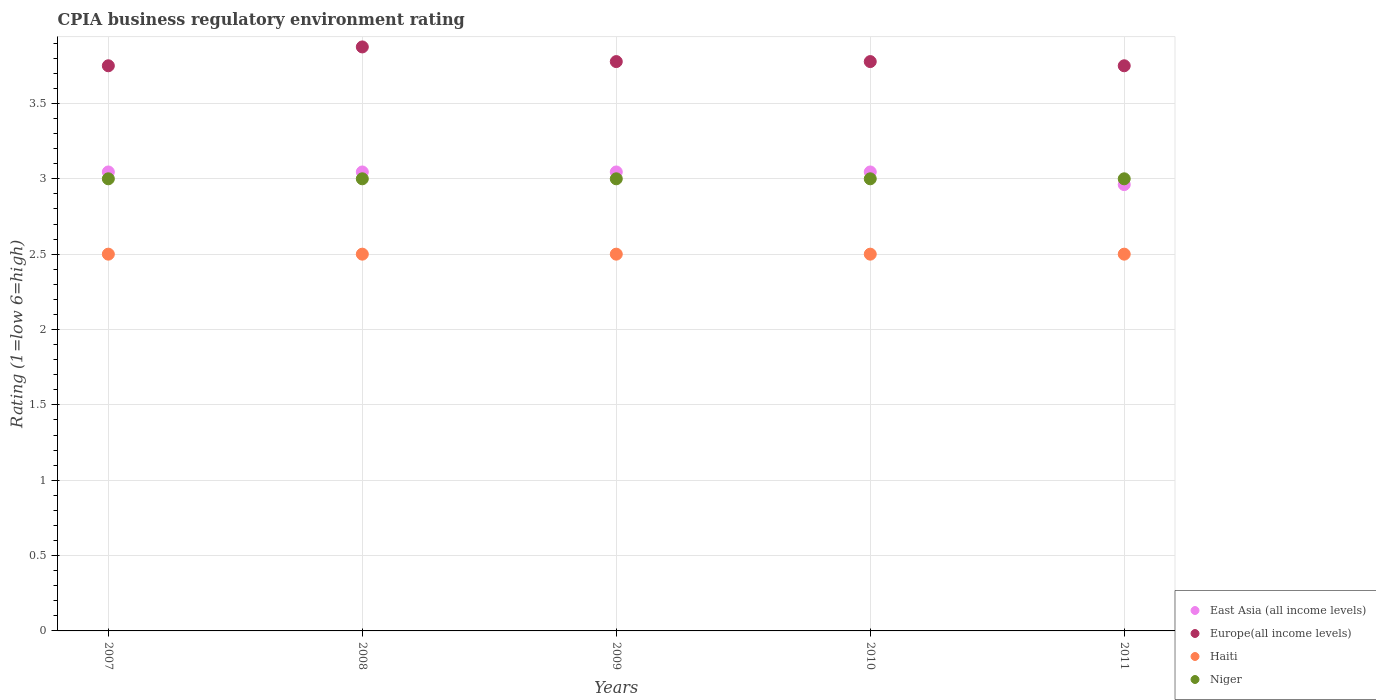How many different coloured dotlines are there?
Provide a short and direct response. 4. Is the number of dotlines equal to the number of legend labels?
Your answer should be compact. Yes. What is the CPIA rating in Europe(all income levels) in 2010?
Ensure brevity in your answer.  3.78. Across all years, what is the maximum CPIA rating in East Asia (all income levels)?
Your answer should be very brief. 3.05. Across all years, what is the minimum CPIA rating in Haiti?
Make the answer very short. 2.5. In which year was the CPIA rating in Haiti maximum?
Offer a terse response. 2007. In which year was the CPIA rating in Niger minimum?
Offer a very short reply. 2007. What is the total CPIA rating in Europe(all income levels) in the graph?
Give a very brief answer. 18.93. What is the difference between the CPIA rating in Europe(all income levels) in 2010 and the CPIA rating in Niger in 2009?
Provide a succinct answer. 0.78. What is the average CPIA rating in Europe(all income levels) per year?
Your answer should be compact. 3.79. In the year 2008, what is the difference between the CPIA rating in Europe(all income levels) and CPIA rating in East Asia (all income levels)?
Make the answer very short. 0.83. In how many years, is the CPIA rating in Haiti greater than 3.6?
Ensure brevity in your answer.  0. Is the difference between the CPIA rating in Europe(all income levels) in 2008 and 2009 greater than the difference between the CPIA rating in East Asia (all income levels) in 2008 and 2009?
Offer a very short reply. Yes. Is the sum of the CPIA rating in East Asia (all income levels) in 2010 and 2011 greater than the maximum CPIA rating in Niger across all years?
Give a very brief answer. Yes. Is it the case that in every year, the sum of the CPIA rating in Europe(all income levels) and CPIA rating in Niger  is greater than the sum of CPIA rating in Haiti and CPIA rating in East Asia (all income levels)?
Make the answer very short. Yes. Is the CPIA rating in Niger strictly greater than the CPIA rating in Haiti over the years?
Your answer should be very brief. Yes. How many dotlines are there?
Ensure brevity in your answer.  4. How many years are there in the graph?
Make the answer very short. 5. Are the values on the major ticks of Y-axis written in scientific E-notation?
Provide a short and direct response. No. Does the graph contain any zero values?
Provide a short and direct response. No. Where does the legend appear in the graph?
Ensure brevity in your answer.  Bottom right. What is the title of the graph?
Your response must be concise. CPIA business regulatory environment rating. Does "Colombia" appear as one of the legend labels in the graph?
Your answer should be compact. No. What is the label or title of the X-axis?
Your answer should be very brief. Years. What is the label or title of the Y-axis?
Keep it short and to the point. Rating (1=low 6=high). What is the Rating (1=low 6=high) of East Asia (all income levels) in 2007?
Offer a very short reply. 3.05. What is the Rating (1=low 6=high) of Europe(all income levels) in 2007?
Provide a short and direct response. 3.75. What is the Rating (1=low 6=high) of East Asia (all income levels) in 2008?
Provide a succinct answer. 3.05. What is the Rating (1=low 6=high) of Europe(all income levels) in 2008?
Keep it short and to the point. 3.88. What is the Rating (1=low 6=high) of East Asia (all income levels) in 2009?
Your response must be concise. 3.05. What is the Rating (1=low 6=high) of Europe(all income levels) in 2009?
Offer a very short reply. 3.78. What is the Rating (1=low 6=high) in Niger in 2009?
Provide a succinct answer. 3. What is the Rating (1=low 6=high) of East Asia (all income levels) in 2010?
Make the answer very short. 3.05. What is the Rating (1=low 6=high) in Europe(all income levels) in 2010?
Provide a short and direct response. 3.78. What is the Rating (1=low 6=high) in Haiti in 2010?
Give a very brief answer. 2.5. What is the Rating (1=low 6=high) in Niger in 2010?
Make the answer very short. 3. What is the Rating (1=low 6=high) of East Asia (all income levels) in 2011?
Make the answer very short. 2.96. What is the Rating (1=low 6=high) of Europe(all income levels) in 2011?
Provide a short and direct response. 3.75. What is the Rating (1=low 6=high) of Haiti in 2011?
Offer a terse response. 2.5. What is the Rating (1=low 6=high) in Niger in 2011?
Offer a terse response. 3. Across all years, what is the maximum Rating (1=low 6=high) of East Asia (all income levels)?
Offer a terse response. 3.05. Across all years, what is the maximum Rating (1=low 6=high) in Europe(all income levels)?
Your response must be concise. 3.88. Across all years, what is the minimum Rating (1=low 6=high) of East Asia (all income levels)?
Offer a very short reply. 2.96. Across all years, what is the minimum Rating (1=low 6=high) in Europe(all income levels)?
Offer a terse response. 3.75. What is the total Rating (1=low 6=high) in East Asia (all income levels) in the graph?
Give a very brief answer. 15.14. What is the total Rating (1=low 6=high) of Europe(all income levels) in the graph?
Provide a succinct answer. 18.93. What is the total Rating (1=low 6=high) of Haiti in the graph?
Provide a short and direct response. 12.5. What is the total Rating (1=low 6=high) in Niger in the graph?
Your answer should be compact. 15. What is the difference between the Rating (1=low 6=high) of Europe(all income levels) in 2007 and that in 2008?
Your response must be concise. -0.12. What is the difference between the Rating (1=low 6=high) of Haiti in 2007 and that in 2008?
Ensure brevity in your answer.  0. What is the difference between the Rating (1=low 6=high) in Europe(all income levels) in 2007 and that in 2009?
Provide a short and direct response. -0.03. What is the difference between the Rating (1=low 6=high) of Haiti in 2007 and that in 2009?
Provide a succinct answer. 0. What is the difference between the Rating (1=low 6=high) in East Asia (all income levels) in 2007 and that in 2010?
Provide a succinct answer. 0. What is the difference between the Rating (1=low 6=high) of Europe(all income levels) in 2007 and that in 2010?
Offer a very short reply. -0.03. What is the difference between the Rating (1=low 6=high) of Haiti in 2007 and that in 2010?
Your answer should be compact. 0. What is the difference between the Rating (1=low 6=high) in East Asia (all income levels) in 2007 and that in 2011?
Provide a short and direct response. 0.08. What is the difference between the Rating (1=low 6=high) of Niger in 2007 and that in 2011?
Provide a short and direct response. 0. What is the difference between the Rating (1=low 6=high) in Europe(all income levels) in 2008 and that in 2009?
Your answer should be very brief. 0.1. What is the difference between the Rating (1=low 6=high) of Haiti in 2008 and that in 2009?
Give a very brief answer. 0. What is the difference between the Rating (1=low 6=high) of Niger in 2008 and that in 2009?
Keep it short and to the point. 0. What is the difference between the Rating (1=low 6=high) of East Asia (all income levels) in 2008 and that in 2010?
Provide a succinct answer. 0. What is the difference between the Rating (1=low 6=high) in Europe(all income levels) in 2008 and that in 2010?
Your response must be concise. 0.1. What is the difference between the Rating (1=low 6=high) in Haiti in 2008 and that in 2010?
Keep it short and to the point. 0. What is the difference between the Rating (1=low 6=high) in East Asia (all income levels) in 2008 and that in 2011?
Make the answer very short. 0.08. What is the difference between the Rating (1=low 6=high) in Europe(all income levels) in 2008 and that in 2011?
Your answer should be compact. 0.12. What is the difference between the Rating (1=low 6=high) of Haiti in 2008 and that in 2011?
Provide a succinct answer. 0. What is the difference between the Rating (1=low 6=high) of East Asia (all income levels) in 2009 and that in 2010?
Give a very brief answer. 0. What is the difference between the Rating (1=low 6=high) of Haiti in 2009 and that in 2010?
Offer a very short reply. 0. What is the difference between the Rating (1=low 6=high) of East Asia (all income levels) in 2009 and that in 2011?
Offer a very short reply. 0.08. What is the difference between the Rating (1=low 6=high) of Europe(all income levels) in 2009 and that in 2011?
Provide a succinct answer. 0.03. What is the difference between the Rating (1=low 6=high) in Haiti in 2009 and that in 2011?
Ensure brevity in your answer.  0. What is the difference between the Rating (1=low 6=high) in East Asia (all income levels) in 2010 and that in 2011?
Ensure brevity in your answer.  0.08. What is the difference between the Rating (1=low 6=high) in Europe(all income levels) in 2010 and that in 2011?
Provide a short and direct response. 0.03. What is the difference between the Rating (1=low 6=high) of East Asia (all income levels) in 2007 and the Rating (1=low 6=high) of Europe(all income levels) in 2008?
Ensure brevity in your answer.  -0.83. What is the difference between the Rating (1=low 6=high) of East Asia (all income levels) in 2007 and the Rating (1=low 6=high) of Haiti in 2008?
Give a very brief answer. 0.55. What is the difference between the Rating (1=low 6=high) of East Asia (all income levels) in 2007 and the Rating (1=low 6=high) of Niger in 2008?
Provide a short and direct response. 0.05. What is the difference between the Rating (1=low 6=high) of Europe(all income levels) in 2007 and the Rating (1=low 6=high) of Haiti in 2008?
Your response must be concise. 1.25. What is the difference between the Rating (1=low 6=high) of Europe(all income levels) in 2007 and the Rating (1=low 6=high) of Niger in 2008?
Offer a very short reply. 0.75. What is the difference between the Rating (1=low 6=high) of East Asia (all income levels) in 2007 and the Rating (1=low 6=high) of Europe(all income levels) in 2009?
Your answer should be compact. -0.73. What is the difference between the Rating (1=low 6=high) of East Asia (all income levels) in 2007 and the Rating (1=low 6=high) of Haiti in 2009?
Make the answer very short. 0.55. What is the difference between the Rating (1=low 6=high) of East Asia (all income levels) in 2007 and the Rating (1=low 6=high) of Niger in 2009?
Give a very brief answer. 0.05. What is the difference between the Rating (1=low 6=high) of Europe(all income levels) in 2007 and the Rating (1=low 6=high) of Haiti in 2009?
Ensure brevity in your answer.  1.25. What is the difference between the Rating (1=low 6=high) in Europe(all income levels) in 2007 and the Rating (1=low 6=high) in Niger in 2009?
Make the answer very short. 0.75. What is the difference between the Rating (1=low 6=high) of East Asia (all income levels) in 2007 and the Rating (1=low 6=high) of Europe(all income levels) in 2010?
Ensure brevity in your answer.  -0.73. What is the difference between the Rating (1=low 6=high) in East Asia (all income levels) in 2007 and the Rating (1=low 6=high) in Haiti in 2010?
Your answer should be compact. 0.55. What is the difference between the Rating (1=low 6=high) of East Asia (all income levels) in 2007 and the Rating (1=low 6=high) of Niger in 2010?
Ensure brevity in your answer.  0.05. What is the difference between the Rating (1=low 6=high) of Europe(all income levels) in 2007 and the Rating (1=low 6=high) of Niger in 2010?
Your answer should be compact. 0.75. What is the difference between the Rating (1=low 6=high) of East Asia (all income levels) in 2007 and the Rating (1=low 6=high) of Europe(all income levels) in 2011?
Offer a very short reply. -0.7. What is the difference between the Rating (1=low 6=high) of East Asia (all income levels) in 2007 and the Rating (1=low 6=high) of Haiti in 2011?
Your answer should be compact. 0.55. What is the difference between the Rating (1=low 6=high) of East Asia (all income levels) in 2007 and the Rating (1=low 6=high) of Niger in 2011?
Offer a terse response. 0.05. What is the difference between the Rating (1=low 6=high) in Europe(all income levels) in 2007 and the Rating (1=low 6=high) in Haiti in 2011?
Make the answer very short. 1.25. What is the difference between the Rating (1=low 6=high) of Europe(all income levels) in 2007 and the Rating (1=low 6=high) of Niger in 2011?
Provide a short and direct response. 0.75. What is the difference between the Rating (1=low 6=high) in East Asia (all income levels) in 2008 and the Rating (1=low 6=high) in Europe(all income levels) in 2009?
Provide a short and direct response. -0.73. What is the difference between the Rating (1=low 6=high) of East Asia (all income levels) in 2008 and the Rating (1=low 6=high) of Haiti in 2009?
Give a very brief answer. 0.55. What is the difference between the Rating (1=low 6=high) in East Asia (all income levels) in 2008 and the Rating (1=low 6=high) in Niger in 2009?
Your response must be concise. 0.05. What is the difference between the Rating (1=low 6=high) of Europe(all income levels) in 2008 and the Rating (1=low 6=high) of Haiti in 2009?
Keep it short and to the point. 1.38. What is the difference between the Rating (1=low 6=high) of Haiti in 2008 and the Rating (1=low 6=high) of Niger in 2009?
Keep it short and to the point. -0.5. What is the difference between the Rating (1=low 6=high) of East Asia (all income levels) in 2008 and the Rating (1=low 6=high) of Europe(all income levels) in 2010?
Make the answer very short. -0.73. What is the difference between the Rating (1=low 6=high) in East Asia (all income levels) in 2008 and the Rating (1=low 6=high) in Haiti in 2010?
Make the answer very short. 0.55. What is the difference between the Rating (1=low 6=high) of East Asia (all income levels) in 2008 and the Rating (1=low 6=high) of Niger in 2010?
Your response must be concise. 0.05. What is the difference between the Rating (1=low 6=high) of Europe(all income levels) in 2008 and the Rating (1=low 6=high) of Haiti in 2010?
Provide a succinct answer. 1.38. What is the difference between the Rating (1=low 6=high) of Haiti in 2008 and the Rating (1=low 6=high) of Niger in 2010?
Offer a terse response. -0.5. What is the difference between the Rating (1=low 6=high) of East Asia (all income levels) in 2008 and the Rating (1=low 6=high) of Europe(all income levels) in 2011?
Give a very brief answer. -0.7. What is the difference between the Rating (1=low 6=high) in East Asia (all income levels) in 2008 and the Rating (1=low 6=high) in Haiti in 2011?
Ensure brevity in your answer.  0.55. What is the difference between the Rating (1=low 6=high) in East Asia (all income levels) in 2008 and the Rating (1=low 6=high) in Niger in 2011?
Your response must be concise. 0.05. What is the difference between the Rating (1=low 6=high) of Europe(all income levels) in 2008 and the Rating (1=low 6=high) of Haiti in 2011?
Ensure brevity in your answer.  1.38. What is the difference between the Rating (1=low 6=high) in Haiti in 2008 and the Rating (1=low 6=high) in Niger in 2011?
Make the answer very short. -0.5. What is the difference between the Rating (1=low 6=high) of East Asia (all income levels) in 2009 and the Rating (1=low 6=high) of Europe(all income levels) in 2010?
Keep it short and to the point. -0.73. What is the difference between the Rating (1=low 6=high) in East Asia (all income levels) in 2009 and the Rating (1=low 6=high) in Haiti in 2010?
Make the answer very short. 0.55. What is the difference between the Rating (1=low 6=high) in East Asia (all income levels) in 2009 and the Rating (1=low 6=high) in Niger in 2010?
Provide a succinct answer. 0.05. What is the difference between the Rating (1=low 6=high) in Europe(all income levels) in 2009 and the Rating (1=low 6=high) in Haiti in 2010?
Your answer should be compact. 1.28. What is the difference between the Rating (1=low 6=high) of Europe(all income levels) in 2009 and the Rating (1=low 6=high) of Niger in 2010?
Your answer should be compact. 0.78. What is the difference between the Rating (1=low 6=high) of East Asia (all income levels) in 2009 and the Rating (1=low 6=high) of Europe(all income levels) in 2011?
Keep it short and to the point. -0.7. What is the difference between the Rating (1=low 6=high) of East Asia (all income levels) in 2009 and the Rating (1=low 6=high) of Haiti in 2011?
Keep it short and to the point. 0.55. What is the difference between the Rating (1=low 6=high) in East Asia (all income levels) in 2009 and the Rating (1=low 6=high) in Niger in 2011?
Ensure brevity in your answer.  0.05. What is the difference between the Rating (1=low 6=high) of Europe(all income levels) in 2009 and the Rating (1=low 6=high) of Haiti in 2011?
Ensure brevity in your answer.  1.28. What is the difference between the Rating (1=low 6=high) of Europe(all income levels) in 2009 and the Rating (1=low 6=high) of Niger in 2011?
Your answer should be very brief. 0.78. What is the difference between the Rating (1=low 6=high) of Haiti in 2009 and the Rating (1=low 6=high) of Niger in 2011?
Ensure brevity in your answer.  -0.5. What is the difference between the Rating (1=low 6=high) in East Asia (all income levels) in 2010 and the Rating (1=low 6=high) in Europe(all income levels) in 2011?
Your response must be concise. -0.7. What is the difference between the Rating (1=low 6=high) of East Asia (all income levels) in 2010 and the Rating (1=low 6=high) of Haiti in 2011?
Your response must be concise. 0.55. What is the difference between the Rating (1=low 6=high) of East Asia (all income levels) in 2010 and the Rating (1=low 6=high) of Niger in 2011?
Your response must be concise. 0.05. What is the difference between the Rating (1=low 6=high) in Europe(all income levels) in 2010 and the Rating (1=low 6=high) in Haiti in 2011?
Your response must be concise. 1.28. What is the difference between the Rating (1=low 6=high) in Haiti in 2010 and the Rating (1=low 6=high) in Niger in 2011?
Your answer should be very brief. -0.5. What is the average Rating (1=low 6=high) in East Asia (all income levels) per year?
Provide a succinct answer. 3.03. What is the average Rating (1=low 6=high) in Europe(all income levels) per year?
Keep it short and to the point. 3.79. What is the average Rating (1=low 6=high) of Niger per year?
Keep it short and to the point. 3. In the year 2007, what is the difference between the Rating (1=low 6=high) of East Asia (all income levels) and Rating (1=low 6=high) of Europe(all income levels)?
Your answer should be compact. -0.7. In the year 2007, what is the difference between the Rating (1=low 6=high) in East Asia (all income levels) and Rating (1=low 6=high) in Haiti?
Ensure brevity in your answer.  0.55. In the year 2007, what is the difference between the Rating (1=low 6=high) of East Asia (all income levels) and Rating (1=low 6=high) of Niger?
Your answer should be compact. 0.05. In the year 2007, what is the difference between the Rating (1=low 6=high) in Europe(all income levels) and Rating (1=low 6=high) in Haiti?
Provide a succinct answer. 1.25. In the year 2007, what is the difference between the Rating (1=low 6=high) of Europe(all income levels) and Rating (1=low 6=high) of Niger?
Provide a short and direct response. 0.75. In the year 2008, what is the difference between the Rating (1=low 6=high) in East Asia (all income levels) and Rating (1=low 6=high) in Europe(all income levels)?
Offer a very short reply. -0.83. In the year 2008, what is the difference between the Rating (1=low 6=high) of East Asia (all income levels) and Rating (1=low 6=high) of Haiti?
Your answer should be compact. 0.55. In the year 2008, what is the difference between the Rating (1=low 6=high) in East Asia (all income levels) and Rating (1=low 6=high) in Niger?
Provide a short and direct response. 0.05. In the year 2008, what is the difference between the Rating (1=low 6=high) of Europe(all income levels) and Rating (1=low 6=high) of Haiti?
Make the answer very short. 1.38. In the year 2009, what is the difference between the Rating (1=low 6=high) in East Asia (all income levels) and Rating (1=low 6=high) in Europe(all income levels)?
Make the answer very short. -0.73. In the year 2009, what is the difference between the Rating (1=low 6=high) of East Asia (all income levels) and Rating (1=low 6=high) of Haiti?
Your response must be concise. 0.55. In the year 2009, what is the difference between the Rating (1=low 6=high) of East Asia (all income levels) and Rating (1=low 6=high) of Niger?
Keep it short and to the point. 0.05. In the year 2009, what is the difference between the Rating (1=low 6=high) in Europe(all income levels) and Rating (1=low 6=high) in Haiti?
Make the answer very short. 1.28. In the year 2010, what is the difference between the Rating (1=low 6=high) in East Asia (all income levels) and Rating (1=low 6=high) in Europe(all income levels)?
Give a very brief answer. -0.73. In the year 2010, what is the difference between the Rating (1=low 6=high) in East Asia (all income levels) and Rating (1=low 6=high) in Haiti?
Give a very brief answer. 0.55. In the year 2010, what is the difference between the Rating (1=low 6=high) in East Asia (all income levels) and Rating (1=low 6=high) in Niger?
Make the answer very short. 0.05. In the year 2010, what is the difference between the Rating (1=low 6=high) of Europe(all income levels) and Rating (1=low 6=high) of Haiti?
Your answer should be very brief. 1.28. In the year 2010, what is the difference between the Rating (1=low 6=high) of Europe(all income levels) and Rating (1=low 6=high) of Niger?
Offer a terse response. 0.78. In the year 2011, what is the difference between the Rating (1=low 6=high) in East Asia (all income levels) and Rating (1=low 6=high) in Europe(all income levels)?
Your answer should be compact. -0.79. In the year 2011, what is the difference between the Rating (1=low 6=high) of East Asia (all income levels) and Rating (1=low 6=high) of Haiti?
Keep it short and to the point. 0.46. In the year 2011, what is the difference between the Rating (1=low 6=high) in East Asia (all income levels) and Rating (1=low 6=high) in Niger?
Your answer should be very brief. -0.04. What is the ratio of the Rating (1=low 6=high) in East Asia (all income levels) in 2007 to that in 2008?
Make the answer very short. 1. What is the ratio of the Rating (1=low 6=high) of Niger in 2007 to that in 2008?
Make the answer very short. 1. What is the ratio of the Rating (1=low 6=high) in Europe(all income levels) in 2007 to that in 2009?
Provide a succinct answer. 0.99. What is the ratio of the Rating (1=low 6=high) of East Asia (all income levels) in 2007 to that in 2010?
Provide a short and direct response. 1. What is the ratio of the Rating (1=low 6=high) in Haiti in 2007 to that in 2010?
Give a very brief answer. 1. What is the ratio of the Rating (1=low 6=high) of Niger in 2007 to that in 2010?
Keep it short and to the point. 1. What is the ratio of the Rating (1=low 6=high) in East Asia (all income levels) in 2007 to that in 2011?
Offer a very short reply. 1.03. What is the ratio of the Rating (1=low 6=high) in Niger in 2007 to that in 2011?
Make the answer very short. 1. What is the ratio of the Rating (1=low 6=high) of Europe(all income levels) in 2008 to that in 2009?
Your answer should be compact. 1.03. What is the ratio of the Rating (1=low 6=high) in Haiti in 2008 to that in 2009?
Ensure brevity in your answer.  1. What is the ratio of the Rating (1=low 6=high) in Niger in 2008 to that in 2009?
Ensure brevity in your answer.  1. What is the ratio of the Rating (1=low 6=high) in East Asia (all income levels) in 2008 to that in 2010?
Give a very brief answer. 1. What is the ratio of the Rating (1=low 6=high) of Europe(all income levels) in 2008 to that in 2010?
Your answer should be very brief. 1.03. What is the ratio of the Rating (1=low 6=high) of Haiti in 2008 to that in 2010?
Your response must be concise. 1. What is the ratio of the Rating (1=low 6=high) in East Asia (all income levels) in 2008 to that in 2011?
Keep it short and to the point. 1.03. What is the ratio of the Rating (1=low 6=high) in Europe(all income levels) in 2008 to that in 2011?
Your answer should be very brief. 1.03. What is the ratio of the Rating (1=low 6=high) of East Asia (all income levels) in 2009 to that in 2010?
Keep it short and to the point. 1. What is the ratio of the Rating (1=low 6=high) of Niger in 2009 to that in 2010?
Offer a terse response. 1. What is the ratio of the Rating (1=low 6=high) in East Asia (all income levels) in 2009 to that in 2011?
Your answer should be very brief. 1.03. What is the ratio of the Rating (1=low 6=high) in Europe(all income levels) in 2009 to that in 2011?
Your answer should be very brief. 1.01. What is the ratio of the Rating (1=low 6=high) in Haiti in 2009 to that in 2011?
Provide a succinct answer. 1. What is the ratio of the Rating (1=low 6=high) of East Asia (all income levels) in 2010 to that in 2011?
Your answer should be very brief. 1.03. What is the ratio of the Rating (1=low 6=high) in Europe(all income levels) in 2010 to that in 2011?
Provide a succinct answer. 1.01. What is the ratio of the Rating (1=low 6=high) in Haiti in 2010 to that in 2011?
Offer a very short reply. 1. What is the difference between the highest and the second highest Rating (1=low 6=high) of East Asia (all income levels)?
Offer a very short reply. 0. What is the difference between the highest and the second highest Rating (1=low 6=high) in Europe(all income levels)?
Your answer should be compact. 0.1. What is the difference between the highest and the lowest Rating (1=low 6=high) in East Asia (all income levels)?
Offer a terse response. 0.08. What is the difference between the highest and the lowest Rating (1=low 6=high) of Niger?
Offer a terse response. 0. 